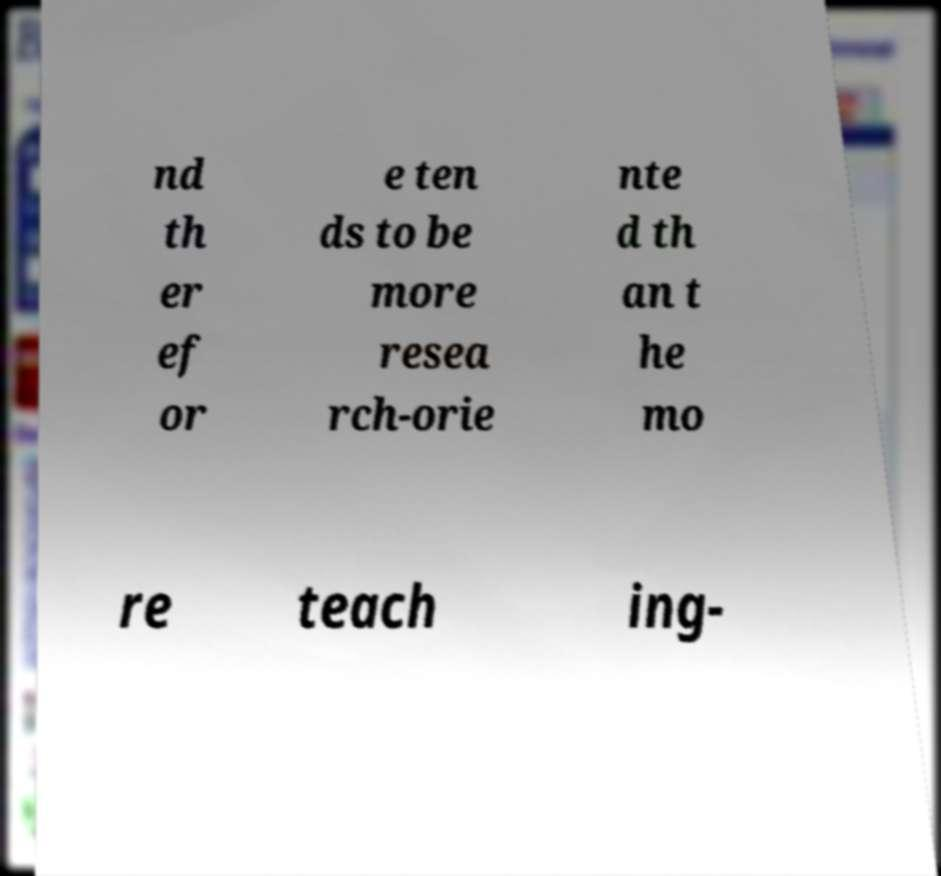Please identify and transcribe the text found in this image. nd th er ef or e ten ds to be more resea rch-orie nte d th an t he mo re teach ing- 